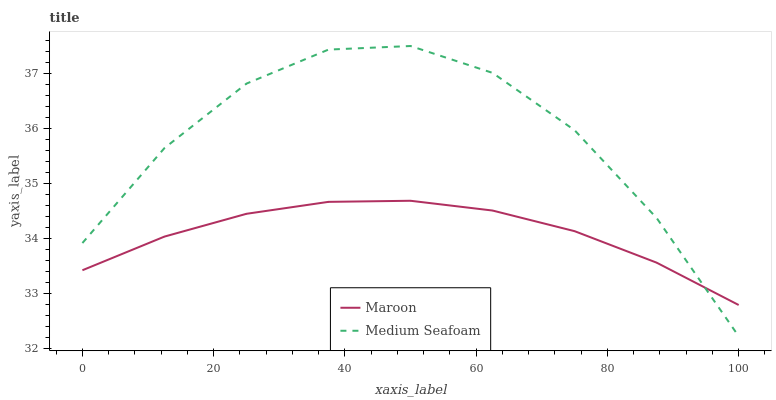Does Maroon have the minimum area under the curve?
Answer yes or no. Yes. Does Medium Seafoam have the maximum area under the curve?
Answer yes or no. Yes. Does Maroon have the maximum area under the curve?
Answer yes or no. No. Is Maroon the smoothest?
Answer yes or no. Yes. Is Medium Seafoam the roughest?
Answer yes or no. Yes. Is Maroon the roughest?
Answer yes or no. No. Does Medium Seafoam have the lowest value?
Answer yes or no. Yes. Does Maroon have the lowest value?
Answer yes or no. No. Does Medium Seafoam have the highest value?
Answer yes or no. Yes. Does Maroon have the highest value?
Answer yes or no. No. Does Maroon intersect Medium Seafoam?
Answer yes or no. Yes. Is Maroon less than Medium Seafoam?
Answer yes or no. No. Is Maroon greater than Medium Seafoam?
Answer yes or no. No. 